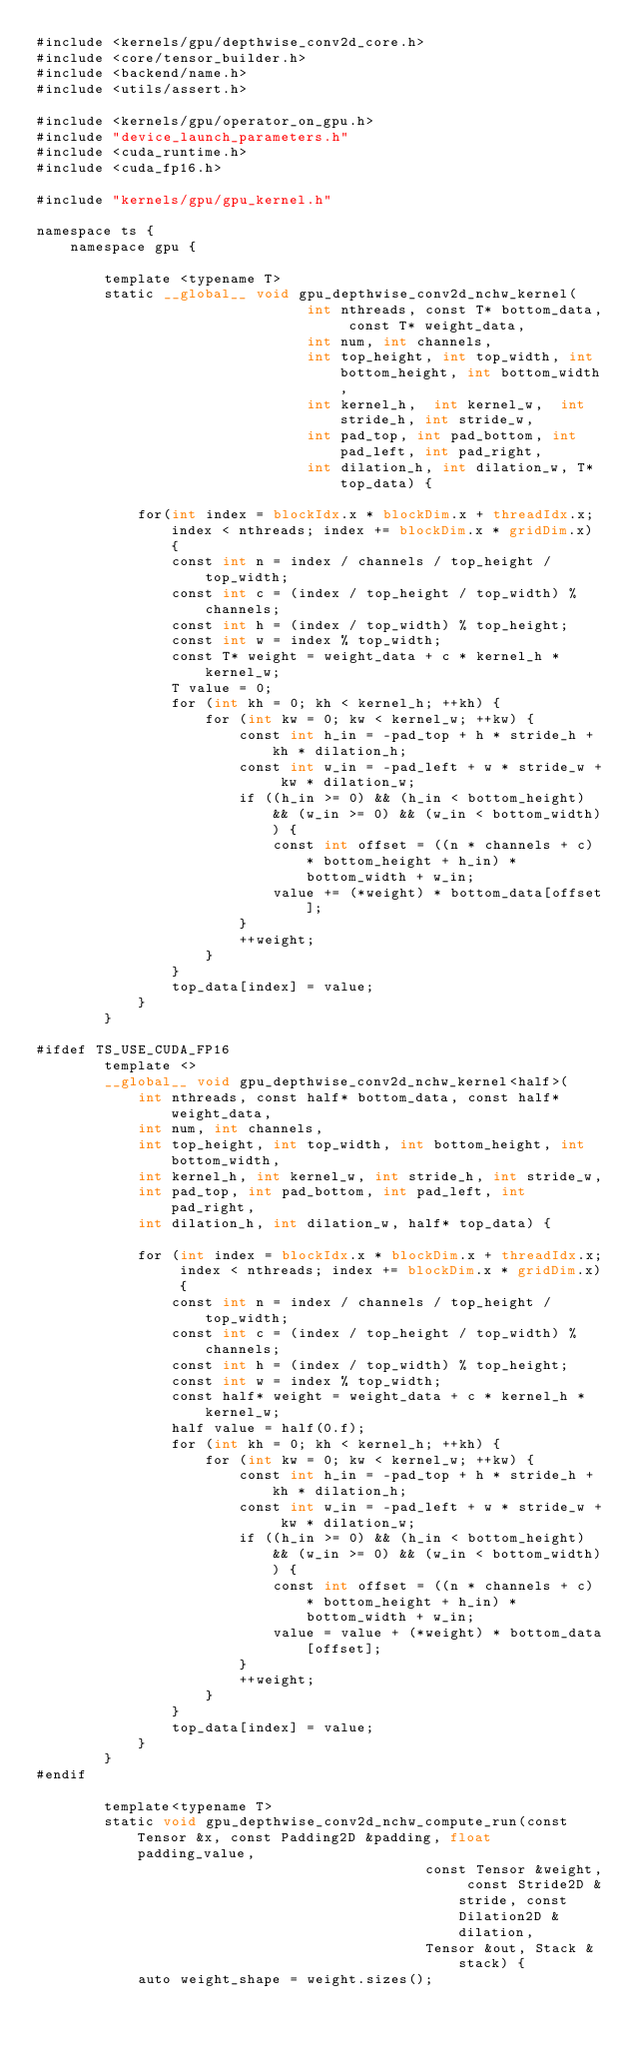<code> <loc_0><loc_0><loc_500><loc_500><_Cuda_>#include <kernels/gpu/depthwise_conv2d_core.h>
#include <core/tensor_builder.h>
#include <backend/name.h>
#include <utils/assert.h>

#include <kernels/gpu/operator_on_gpu.h>
#include "device_launch_parameters.h"
#include <cuda_runtime.h>
#include <cuda_fp16.h>

#include "kernels/gpu/gpu_kernel.h"

namespace ts {
    namespace gpu {

        template <typename T>
        static __global__ void gpu_depthwise_conv2d_nchw_kernel(
                                int nthreads, const T* bottom_data, const T* weight_data, 
                                int num, int channels,
                                int top_height, int top_width, int bottom_height, int bottom_width,
                                int kernel_h,  int kernel_w,  int stride_h, int stride_w,
                                int pad_top, int pad_bottom, int pad_left, int pad_right, 
                                int dilation_h, int dilation_w, T* top_data) {

            for(int index = blockIdx.x * blockDim.x + threadIdx.x; index < nthreads; index += blockDim.x * gridDim.x) {
                const int n = index / channels / top_height / top_width;
                const int c = (index / top_height / top_width) % channels;
                const int h = (index / top_width) % top_height;
                const int w = index % top_width;
                const T* weight = weight_data + c * kernel_h * kernel_w;
                T value = 0;
                for (int kh = 0; kh < kernel_h; ++kh) {
                    for (int kw = 0; kw < kernel_w; ++kw) {
                        const int h_in = -pad_top + h * stride_h + kh * dilation_h;
                        const int w_in = -pad_left + w * stride_w + kw * dilation_w;
                        if ((h_in >= 0) && (h_in < bottom_height) && (w_in >= 0) && (w_in < bottom_width)) {
                            const int offset = ((n * channels + c) * bottom_height + h_in) * bottom_width + w_in;
                            value += (*weight) * bottom_data[offset];
                        }
                        ++weight;
                    }
                }
                top_data[index] = value;
            }
        }

#ifdef TS_USE_CUDA_FP16
        template <>
        __global__ void gpu_depthwise_conv2d_nchw_kernel<half>(
            int nthreads, const half* bottom_data, const half* weight_data,
            int num, int channels,
            int top_height, int top_width, int bottom_height, int bottom_width,
            int kernel_h, int kernel_w, int stride_h, int stride_w,
            int pad_top, int pad_bottom, int pad_left, int pad_right,
            int dilation_h, int dilation_w, half* top_data) {

            for (int index = blockIdx.x * blockDim.x + threadIdx.x; index < nthreads; index += blockDim.x * gridDim.x) {
                const int n = index / channels / top_height / top_width;
                const int c = (index / top_height / top_width) % channels;
                const int h = (index / top_width) % top_height;
                const int w = index % top_width;
                const half* weight = weight_data + c * kernel_h * kernel_w;
                half value = half(0.f);
                for (int kh = 0; kh < kernel_h; ++kh) {
                    for (int kw = 0; kw < kernel_w; ++kw) {
                        const int h_in = -pad_top + h * stride_h + kh * dilation_h;
                        const int w_in = -pad_left + w * stride_w + kw * dilation_w;
                        if ((h_in >= 0) && (h_in < bottom_height) && (w_in >= 0) && (w_in < bottom_width)) {
                            const int offset = ((n * channels + c) * bottom_height + h_in) * bottom_width + w_in;
                            value = value + (*weight) * bottom_data[offset];
                        }
                        ++weight;
                    }
                }
                top_data[index] = value;
            }
        }
#endif

        template<typename T>
        static void gpu_depthwise_conv2d_nchw_compute_run(const Tensor &x, const Padding2D &padding, float padding_value,
                                              const Tensor &weight, const Stride2D &stride, const Dilation2D &dilation,
                                              Tensor &out, Stack &stack) {
            auto weight_shape = weight.sizes();</code> 